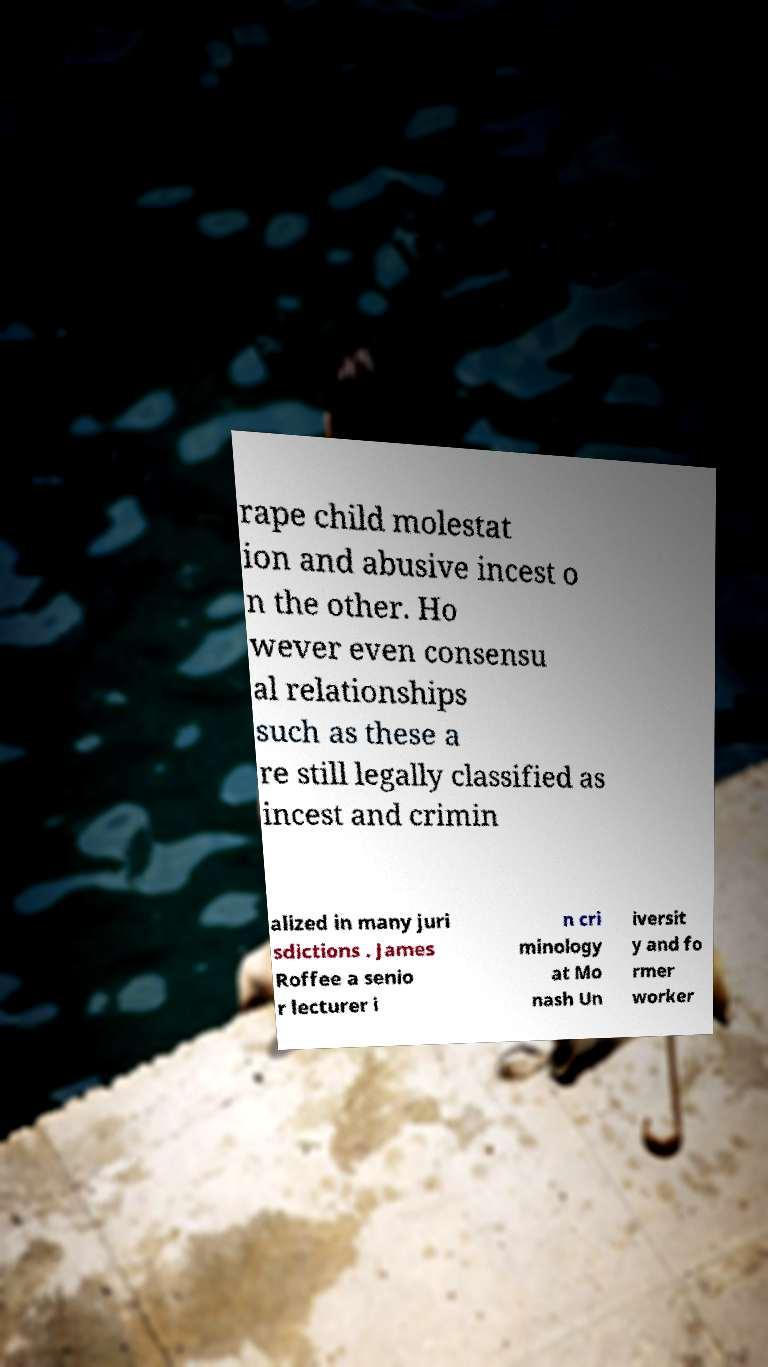Could you assist in decoding the text presented in this image and type it out clearly? rape child molestat ion and abusive incest o n the other. Ho wever even consensu al relationships such as these a re still legally classified as incest and crimin alized in many juri sdictions . James Roffee a senio r lecturer i n cri minology at Mo nash Un iversit y and fo rmer worker 